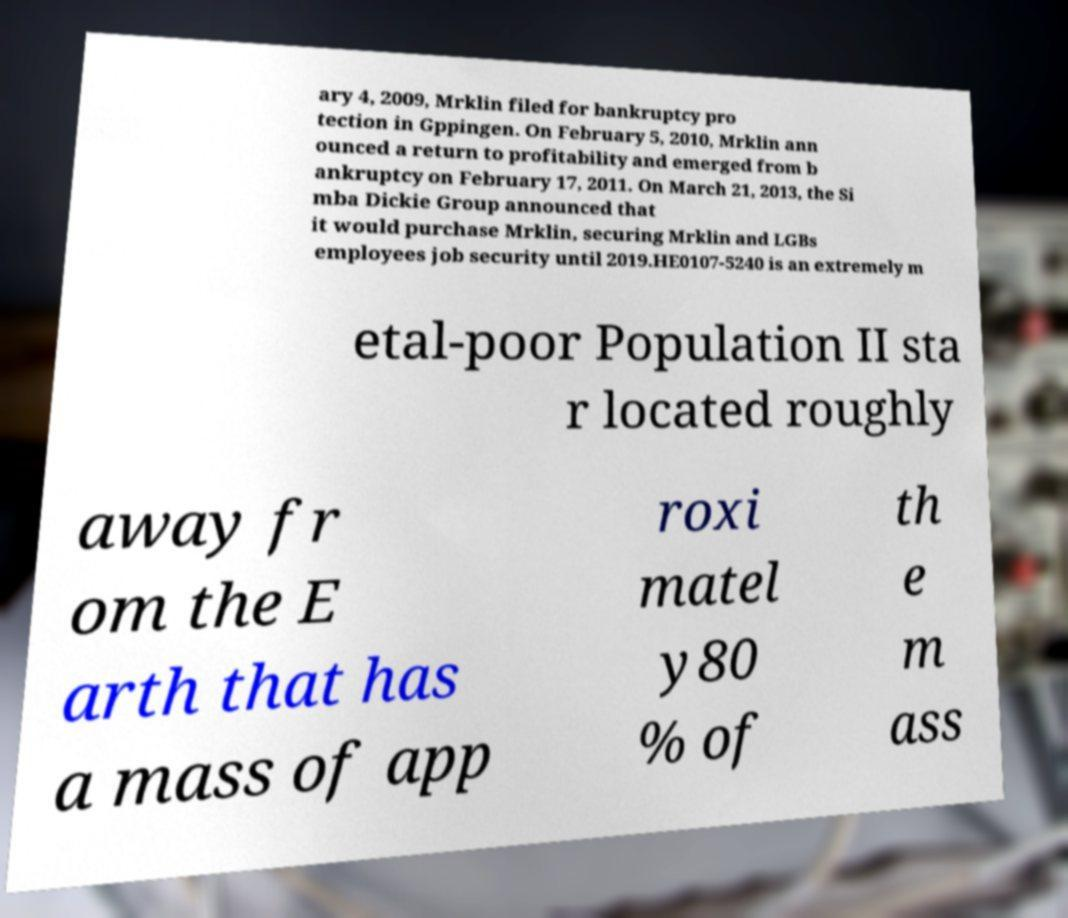Could you extract and type out the text from this image? ary 4, 2009, Mrklin filed for bankruptcy pro tection in Gppingen. On February 5, 2010, Mrklin ann ounced a return to profitability and emerged from b ankruptcy on February 17, 2011. On March 21, 2013, the Si mba Dickie Group announced that it would purchase Mrklin, securing Mrklin and LGBs employees job security until 2019.HE0107-5240 is an extremely m etal-poor Population II sta r located roughly away fr om the E arth that has a mass of app roxi matel y80 % of th e m ass 